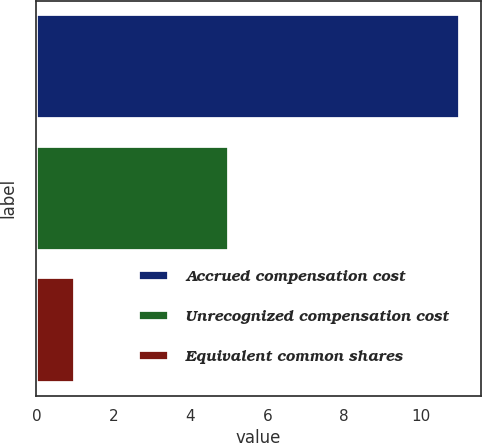<chart> <loc_0><loc_0><loc_500><loc_500><bar_chart><fcel>Accrued compensation cost<fcel>Unrecognized compensation cost<fcel>Equivalent common shares<nl><fcel>11<fcel>5<fcel>1<nl></chart> 